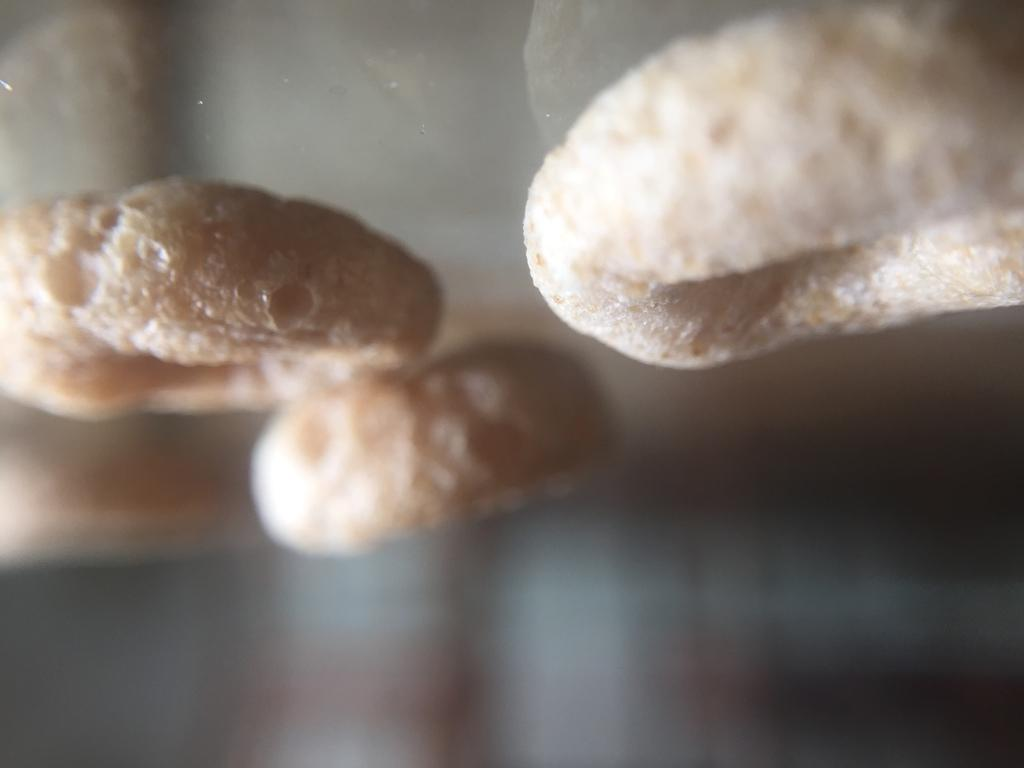What type of item can be seen in the image? There is an eatable item in the image. Can you describe the shape of the eatable item? The eatable item is in a circular shape. What is the income of the person who created the circular eatable item in the image? There is no information about the creator of the eatable item or their income in the image. 